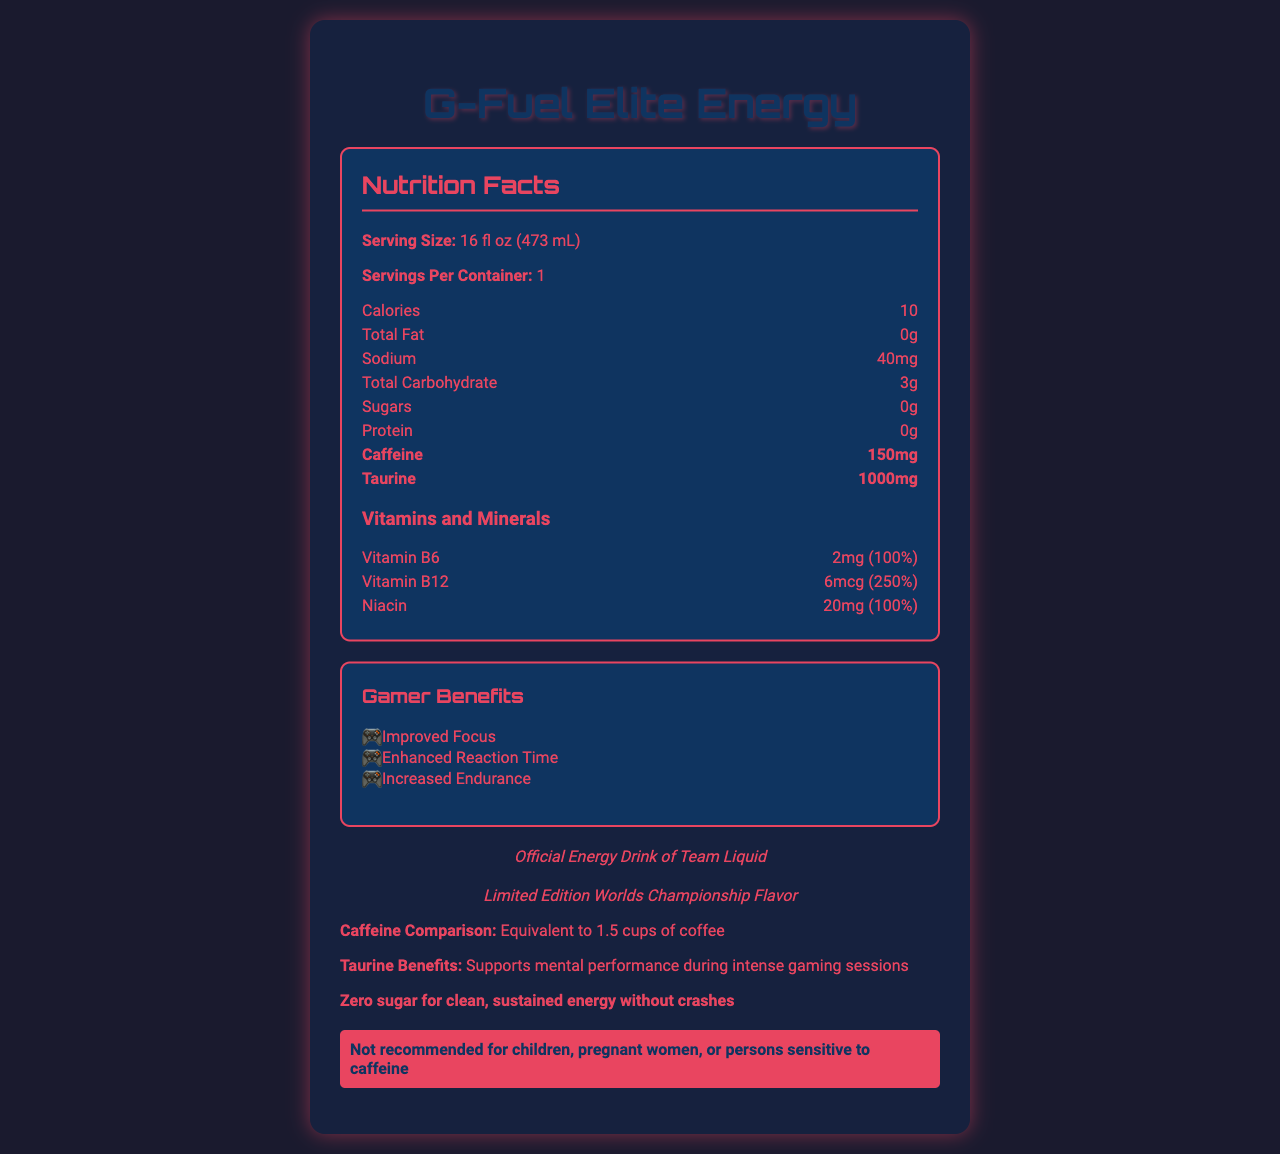what is the serving size? The serving size is explicitly mentioned in the document as 16 fl oz (473 mL).
Answer: 16 fl oz (473 mL) how many calories are in one serving? The nutrition label states that there are 10 calories per serving.
Answer: 10 what is the amount of caffeine per serving? The document highlights the caffeine content as 150mg.
Answer: 150mg what is the taurine content per serving? The taurine content is highlighted and stated as 1000mg.
Answer: 1000mg what vitamins and minerals are included and their daily value percentages? The vitamins and minerals section lists them along with their daily value percentages.
Answer: Vitamin B6 (100%), Vitamin B12 (250%), Niacin (100%) which esports team endorses this product? The document states that it is the official energy drink of Team Liquid.
Answer: Team Liquid how does the caffeine content in the drink compare to coffee? A. 1 cup of coffee B. 1.5 cups of coffee C. 2 cups of coffee D. 3 cups of coffee The document mentions that the caffeine content is equivalent to 1.5 cups of coffee.
Answer: B which of the following benefits does the drink claim to provide? A. Improved Memory B. Enhanced Reaction Time C. Increased Strength D. Better Sleep The gamer benefits section claims enhanced reaction time, improved focus, and increased endurance.
Answer: B Is this product sugar-free? The document claims "Zero sugar for clean, sustained energy without crashes."
Answer: Yes Is it safe for children to consume this drink? The warning section mentions that it is not recommended for children.
Answer: No Summarize the main idea of the document. This summary covers the product name, serving information, highlighted nutrition content, gamer benefits, endorsements, and special edition details.
Answer: The document provides detailed nutrition facts for "G-Fuel Elite Energy," highlighting caffeine and taurine content, vitamins, and gamer benefits. It is the endorsed energy drink of Team Liquid and comes with a World's Championship special flavor. what is the exact amount of potassium in the drink? The document does not provide the amount of potassium content in the drink.
Answer: Not enough information 